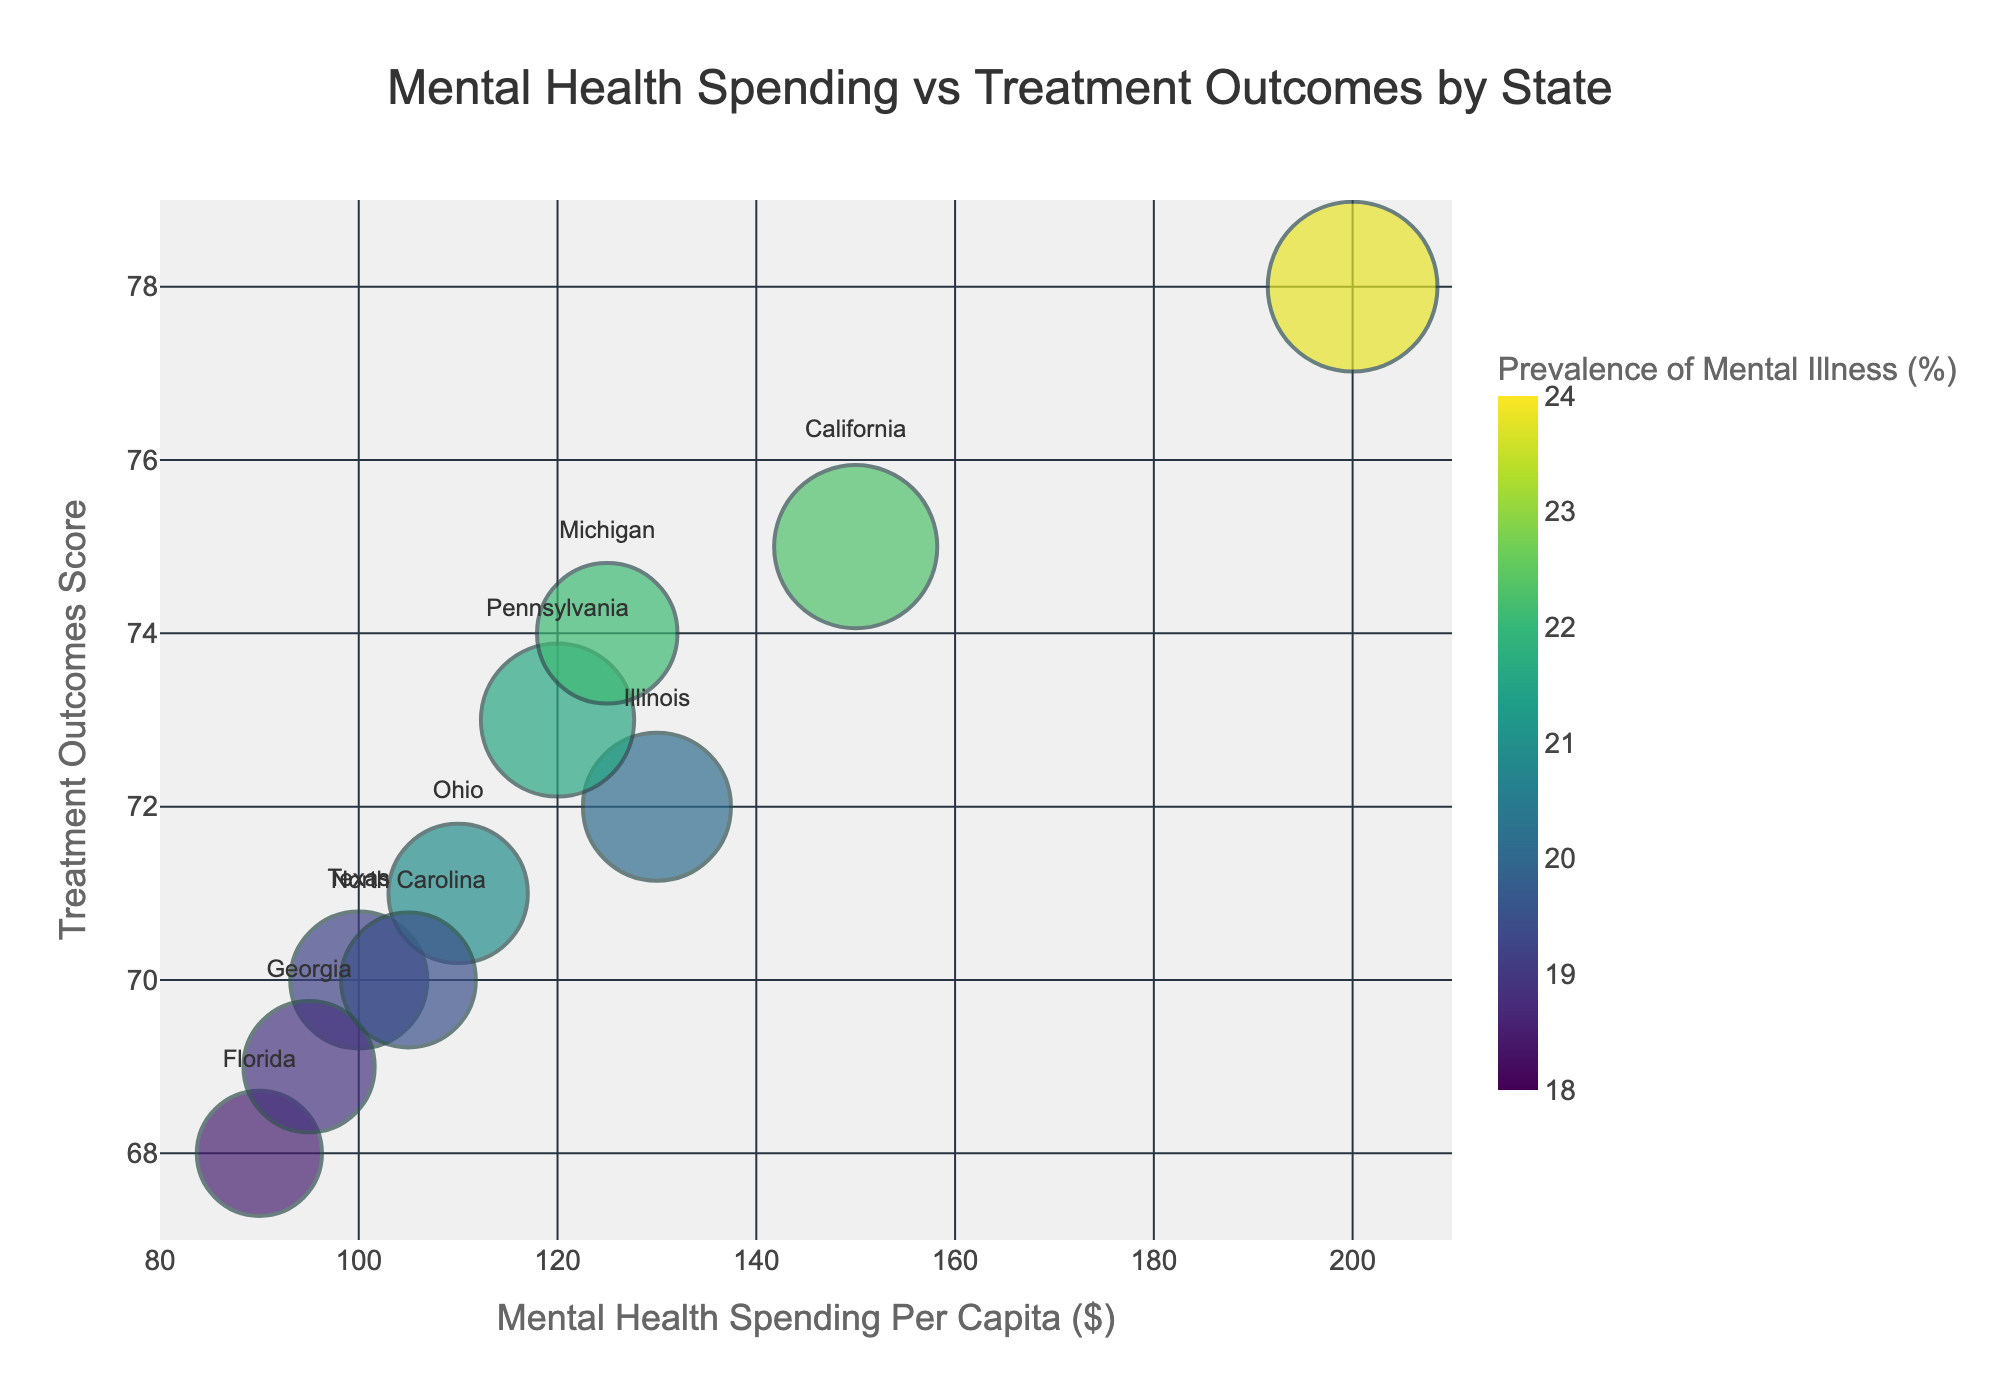What is the title of the chart? The title of a plot is usually found at the top and summarizes what the chart is about. Here, it indicates that the chart is about the relationship between Mental Health Spending and Treatment Outcomes by State.
Answer: Mental Health Spending vs Treatment Outcomes by State Which state has the highest treatment outcomes? Look at the "Treatment Outcomes" axis and find the bubble that is located at the highest y-value. The state name is labeled near the bubble.
Answer: New York How many states are represented in the chart? Count the number of unique bubbles in the plot, as each bubble represents a different state.
Answer: 10 What is the prevalence of mental illness in California? Hover over or look at the bubble corresponding to California and noted the color, which relates to the "Prevalence of Mental Illness" as per the color bar. California is 22.3%.
Answer: 22.3% Which state has the most number of facilities and what is its treatment outcome score? Look for the largest bubble (size of the bubble indicates the number of facilities) and check the state label and the y-value that corresponds to the treatment outcome. New York has the largest bubble and its treatment outcome score is 78.
Answer: New York, 78 What is the average mental health spending per capita of all the states represented? To find the average, sum the mental health spending per capita for all states and divide by the number of states: (150+100+200+90+130+120+110+125+95+105) / 10 = 122.5.
Answer: 122.5 How does the mental health spending per capita in Texas compare with that in Illinois? Check the positions of Texas and Illinois on the x-axis (Mental Health Spending Per Capita) and determine which one is higher or lower. Texas spends 100, while Illinois spends 130.
Answer: Texas spends less than Illinois Which state has the lowest mental health spending per capita and what is that amount? Look at the lowest x-axis value and identify the state associated with that bubble. This is Florida with 90.
Answer: Florida, 90 Is there a bubble that has approximately the same number of facilities as North Carolina but different mental health spending? Which state is it? Identify the bubble corresponding to North Carolina, then look for another bubble with a similar size and check its position on the x-axis to determine if the spending per capita differs. Georgia has 550 facilities and 95 spending, while North Carolina has 580 facilities and 105 spending.
Answer: Georgia What is the overall trend in the relationship between mental health spending and treatment outcomes in the chart? Generally observe the trend of the bubbles, if they tend to move upwards with higher spending, the relationship is positive. In this chart, as mental health spending per capita increases, the treatment outcomes tend to improve.
Answer: Positive correlation between spending and treatment outcomes 